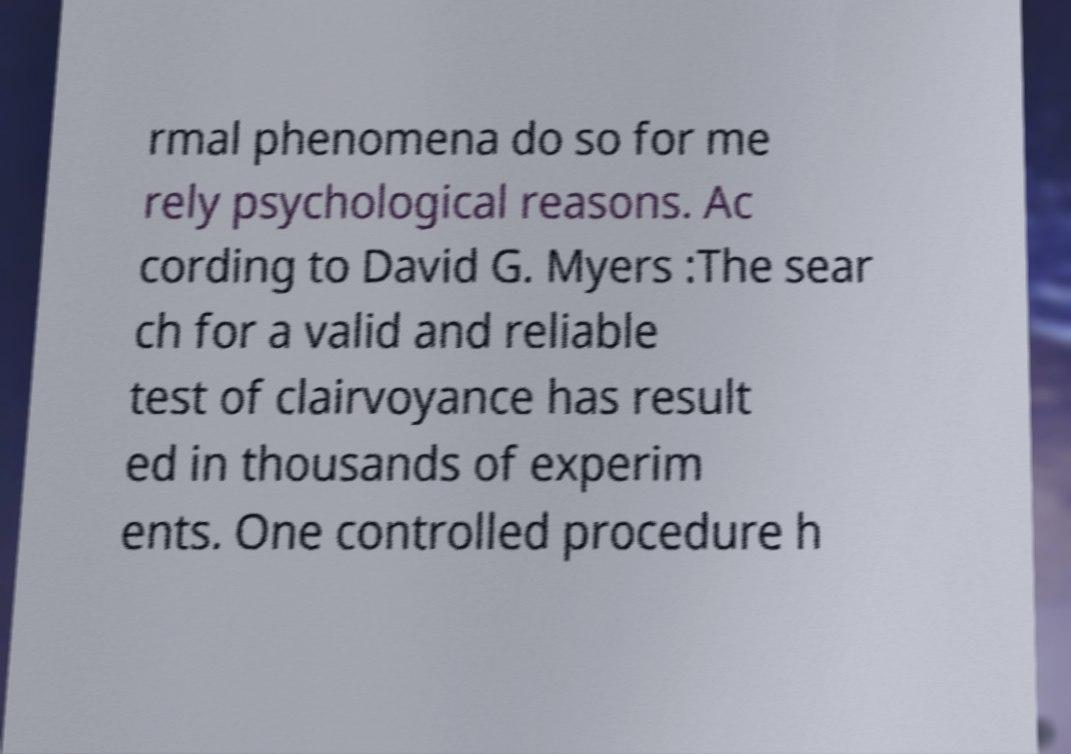Can you accurately transcribe the text from the provided image for me? rmal phenomena do so for me rely psychological reasons. Ac cording to David G. Myers :The sear ch for a valid and reliable test of clairvoyance has result ed in thousands of experim ents. One controlled procedure h 